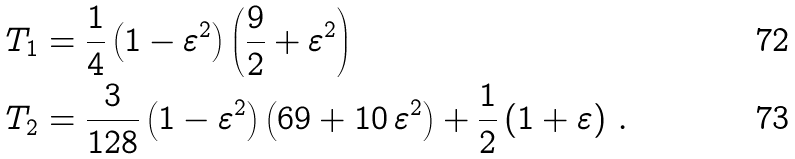<formula> <loc_0><loc_0><loc_500><loc_500>T _ { 1 } & = \frac { 1 } { 4 } \left ( 1 - \varepsilon ^ { 2 } \right ) \left ( \frac { 9 } { 2 } + \varepsilon ^ { 2 } \right ) \\ T _ { 2 } & = \frac { 3 } { 1 2 8 } \left ( 1 - \varepsilon ^ { 2 } \right ) \left ( 6 9 + 1 0 \, \varepsilon ^ { 2 } \right ) + \frac { 1 } { 2 } \left ( 1 + \varepsilon \right ) \, .</formula> 